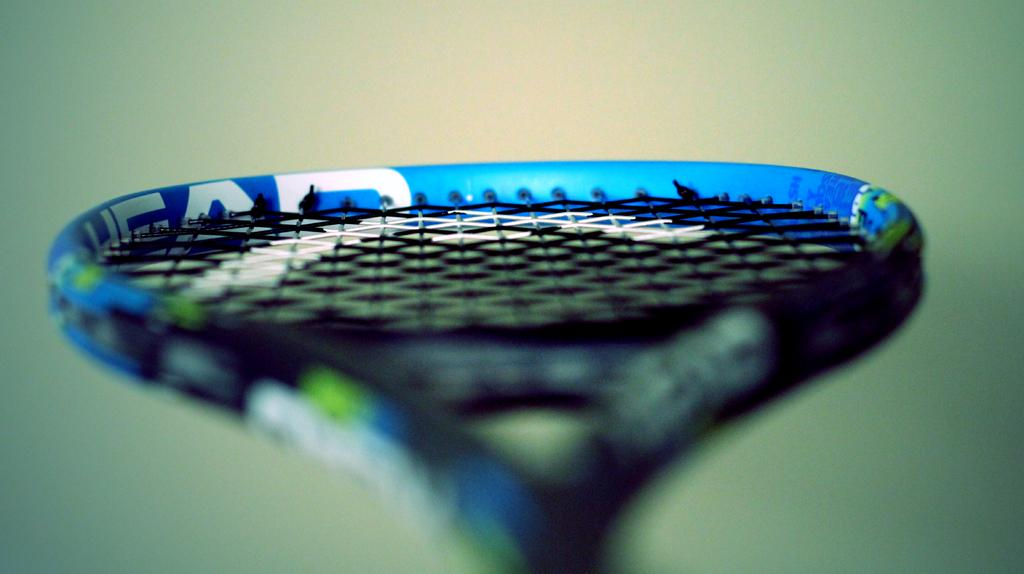What sports equipment is present in the image? There is a tennis racket in the image. Can you describe the background of the image? The background of the image is blurred. What type of milk is being poured into the glass in the image? There is no glass or milk present in the image; it only features a tennis racket. 